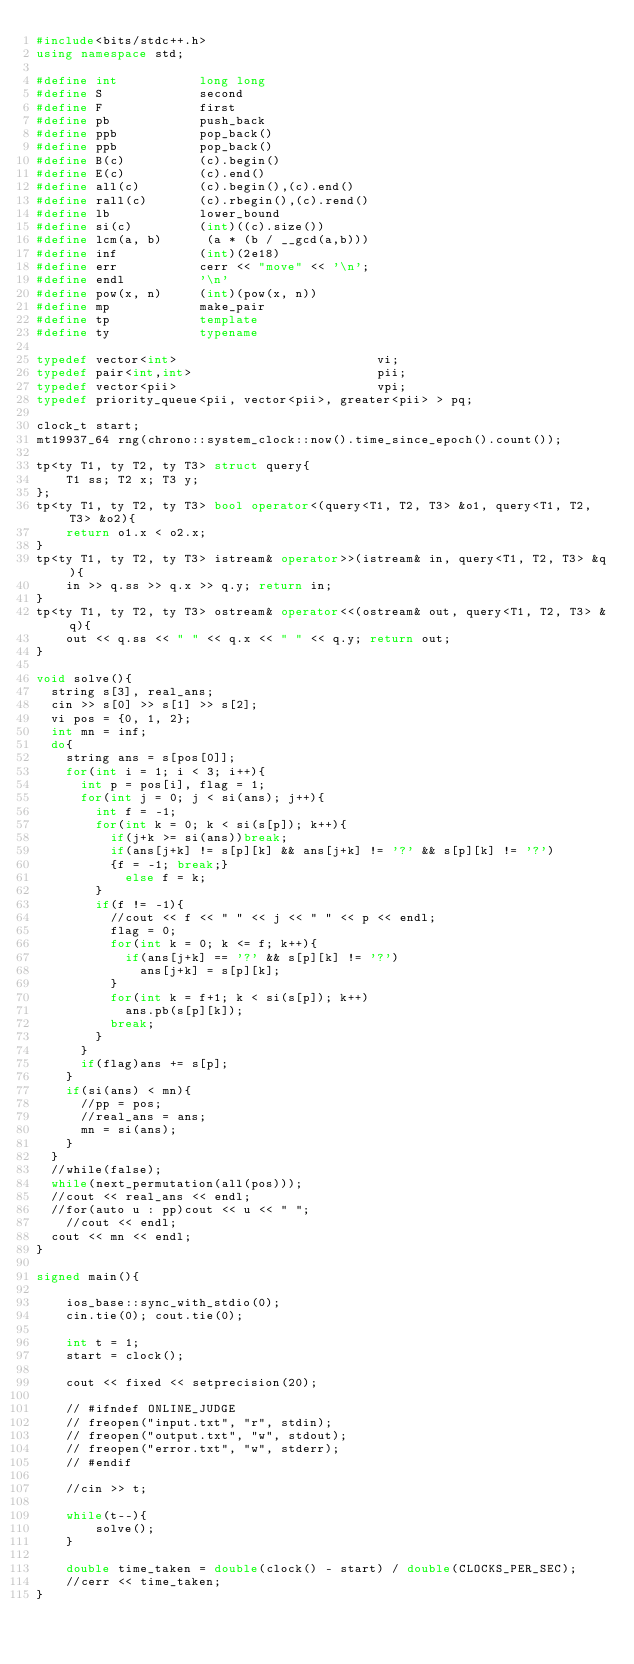<code> <loc_0><loc_0><loc_500><loc_500><_C++_>#include<bits/stdc++.h>
using namespace std;

#define int           long long
#define S             second
#define F             first
#define pb            push_back
#define ppb           pop_back()
#define ppb           pop_back()
#define B(c)          (c).begin()
#define E(c)          (c).end()
#define all(c)        (c).begin(),(c).end()
#define rall(c)       (c).rbegin(),(c).rend() 
#define lb            lower_bound
#define si(c)         (int)((c).size())
#define lcm(a, b)      (a * (b / __gcd(a,b)))  
#define inf           (int)(2e18)
#define err           cerr << "move" << '\n';
#define endl          '\n'
#define pow(x, n)     (int)(pow(x, n))
#define mp            make_pair
#define tp            template
#define ty            typename

typedef vector<int>                           vi;
typedef pair<int,int>                         pii;
typedef vector<pii>                           vpi;
typedef priority_queue<pii, vector<pii>, greater<pii> > pq;

clock_t start;
mt19937_64 rng(chrono::system_clock::now().time_since_epoch().count());

tp<ty T1, ty T2, ty T3> struct query{
    T1 ss; T2 x; T3 y;
};
tp<ty T1, ty T2, ty T3> bool operator<(query<T1, T2, T3> &o1, query<T1, T2, T3> &o2){
    return o1.x < o2.x;
}
tp<ty T1, ty T2, ty T3> istream& operator>>(istream& in, query<T1, T2, T3> &q){
    in >> q.ss >> q.x >> q.y; return in;
}
tp<ty T1, ty T2, ty T3> ostream& operator<<(ostream& out, query<T1, T2, T3> &q){
    out << q.ss << " " << q.x << " " << q.y; return out;
}

void solve(){
	string s[3], real_ans;
	cin >> s[0] >> s[1] >> s[2];
	vi pos = {0, 1, 2};
	int mn = inf;
	do{
		string ans = s[pos[0]];
		for(int i = 1; i < 3; i++){
			int p = pos[i], flag = 1;
			for(int j = 0; j < si(ans); j++){
				int f = -1;
				for(int k = 0; k < si(s[p]); k++){
					if(j+k >= si(ans))break;
					if(ans[j+k] != s[p][k] && ans[j+k] != '?' && s[p][k] != '?')
					{f = -1; break;}
				    else f = k;
				}
				if(f != -1){
					//cout << f << " " << j << " " << p << endl;
					flag = 0;
					for(int k = 0; k <= f; k++){
						if(ans[j+k] == '?' && s[p][k] != '?')
							ans[j+k] = s[p][k];
					}
					for(int k = f+1; k < si(s[p]); k++)
						ans.pb(s[p][k]);
					break;
				}
			}
			if(flag)ans += s[p];
		}
		if(si(ans) < mn){
			//pp = pos;
			//real_ans = ans;
			mn = si(ans);
		}
	}
	//while(false);
	while(next_permutation(all(pos)));
	//cout << real_ans << endl;
	//for(auto u : pp)cout << u << " ";
		//cout << endl;
 	cout << mn << endl;
}

signed main(){

    ios_base::sync_with_stdio(0); 
    cin.tie(0); cout.tie(0);   

    int t = 1;
    start = clock(); 

    cout << fixed << setprecision(20);

    // #ifndef ONLINE_JUDGE
    // freopen("input.txt", "r", stdin); 
    // freopen("output.txt", "w", stdout);
    // freopen("error.txt", "w", stderr);
    // #endif

    //cin >> t;
    
    while(t--){
        solve();
    }

    double time_taken = double(clock() - start) / double(CLOCKS_PER_SEC); 
    //cerr << time_taken;
}
</code> 